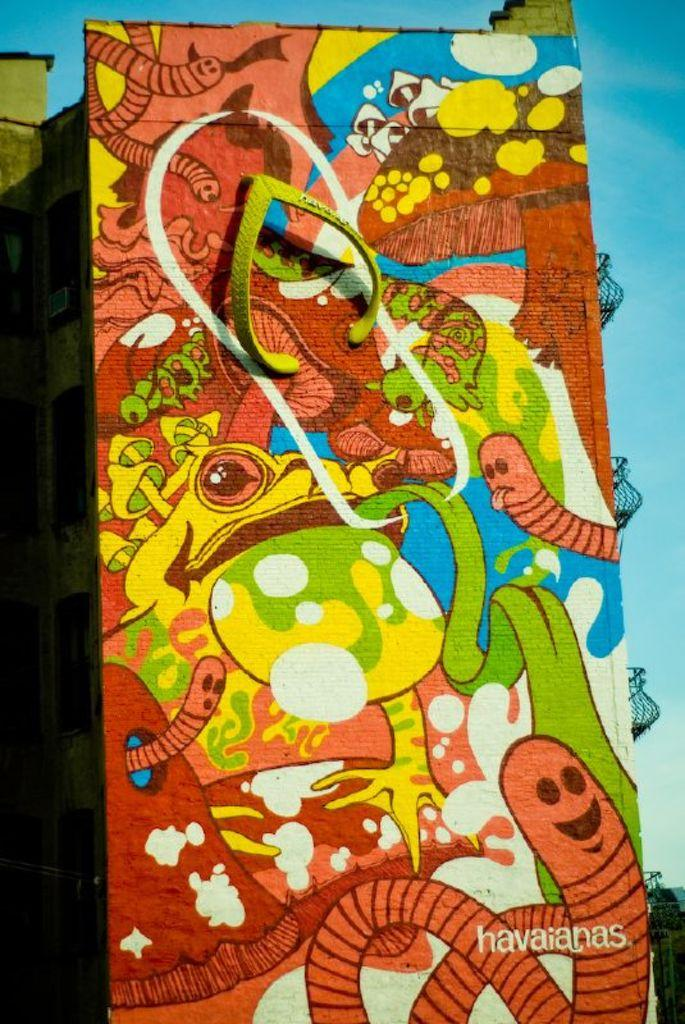Provide a one-sentence caption for the provided image. a painting of worms and frogs by havaianas. 